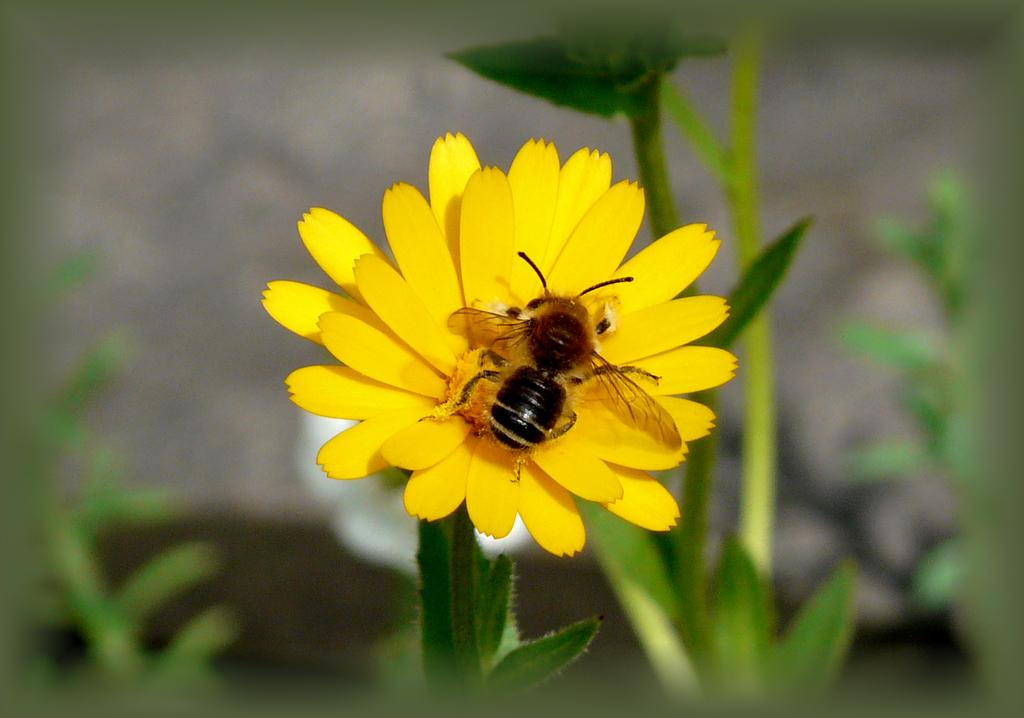What is the main subject of the image? There is a flower in the image. What color is the flower? The flower is yellow. Is there any other living creature present in the image? Yes, there is a bee on the flower. What can be seen in the background of the image? There is a plant in the background of the image. How would you describe the background of the image? The background is blurred. What type of acoustics can be heard from the flower in the image? There is no sound or acoustics associated with the flower in the image. What letters are visible on the bee in the image? There are no letters present on the bee in the image. 